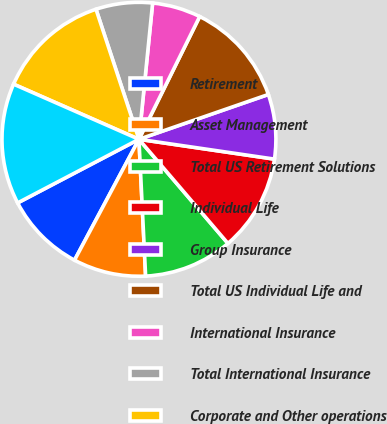Convert chart. <chart><loc_0><loc_0><loc_500><loc_500><pie_chart><fcel>Retirement<fcel>Asset Management<fcel>Total US Retirement Solutions<fcel>Individual Life<fcel>Group Insurance<fcel>Total US Individual Life and<fcel>International Insurance<fcel>Total International Insurance<fcel>Corporate and Other operations<fcel>Total Corporate and Other<nl><fcel>9.52%<fcel>8.57%<fcel>10.48%<fcel>11.43%<fcel>7.62%<fcel>12.38%<fcel>5.72%<fcel>6.67%<fcel>13.33%<fcel>14.28%<nl></chart> 